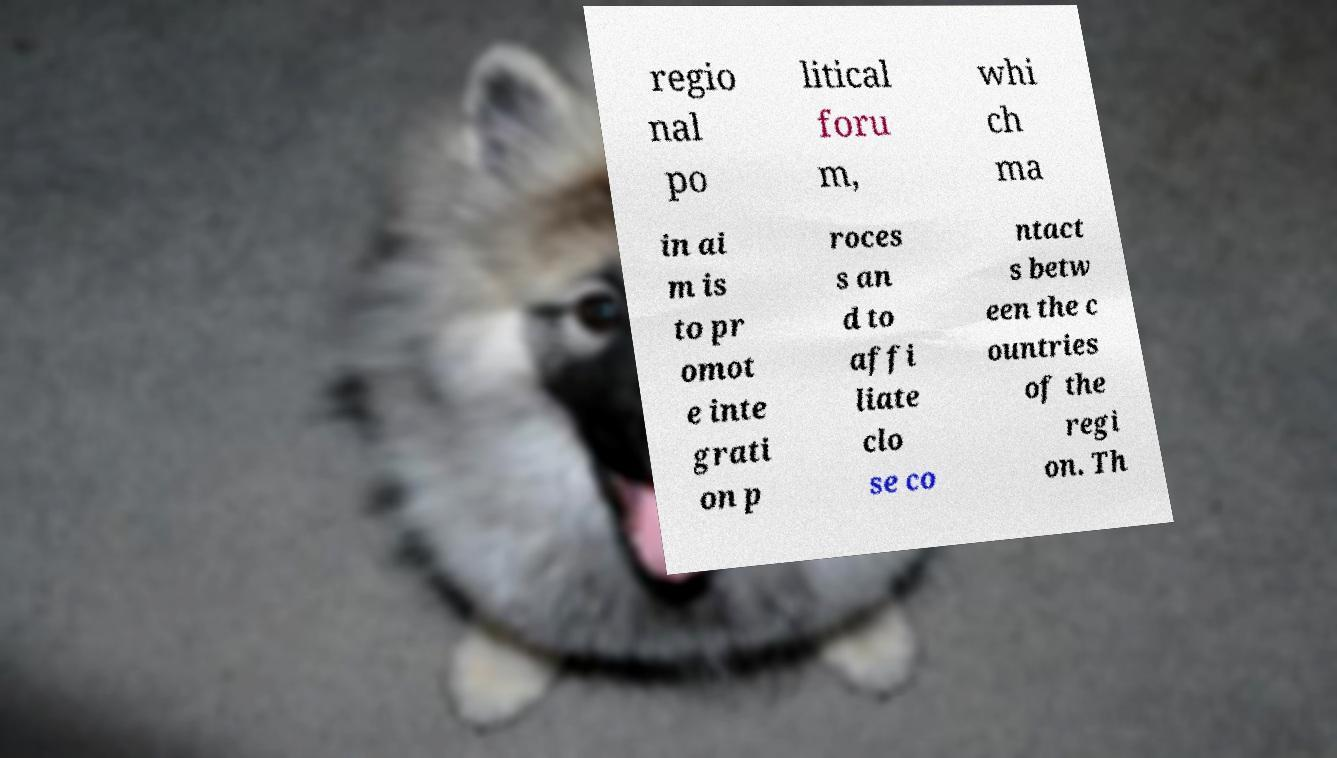Please read and relay the text visible in this image. What does it say? regio nal po litical foru m, whi ch ma in ai m is to pr omot e inte grati on p roces s an d to affi liate clo se co ntact s betw een the c ountries of the regi on. Th 